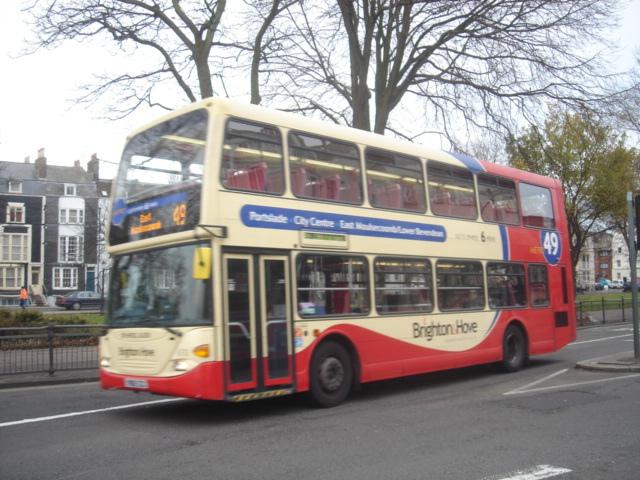Is the bus in motion?
Be succinct. Yes. Is the bus parked on the street?
Short answer required. No. What is the bus number?
Concise answer only. 49. 